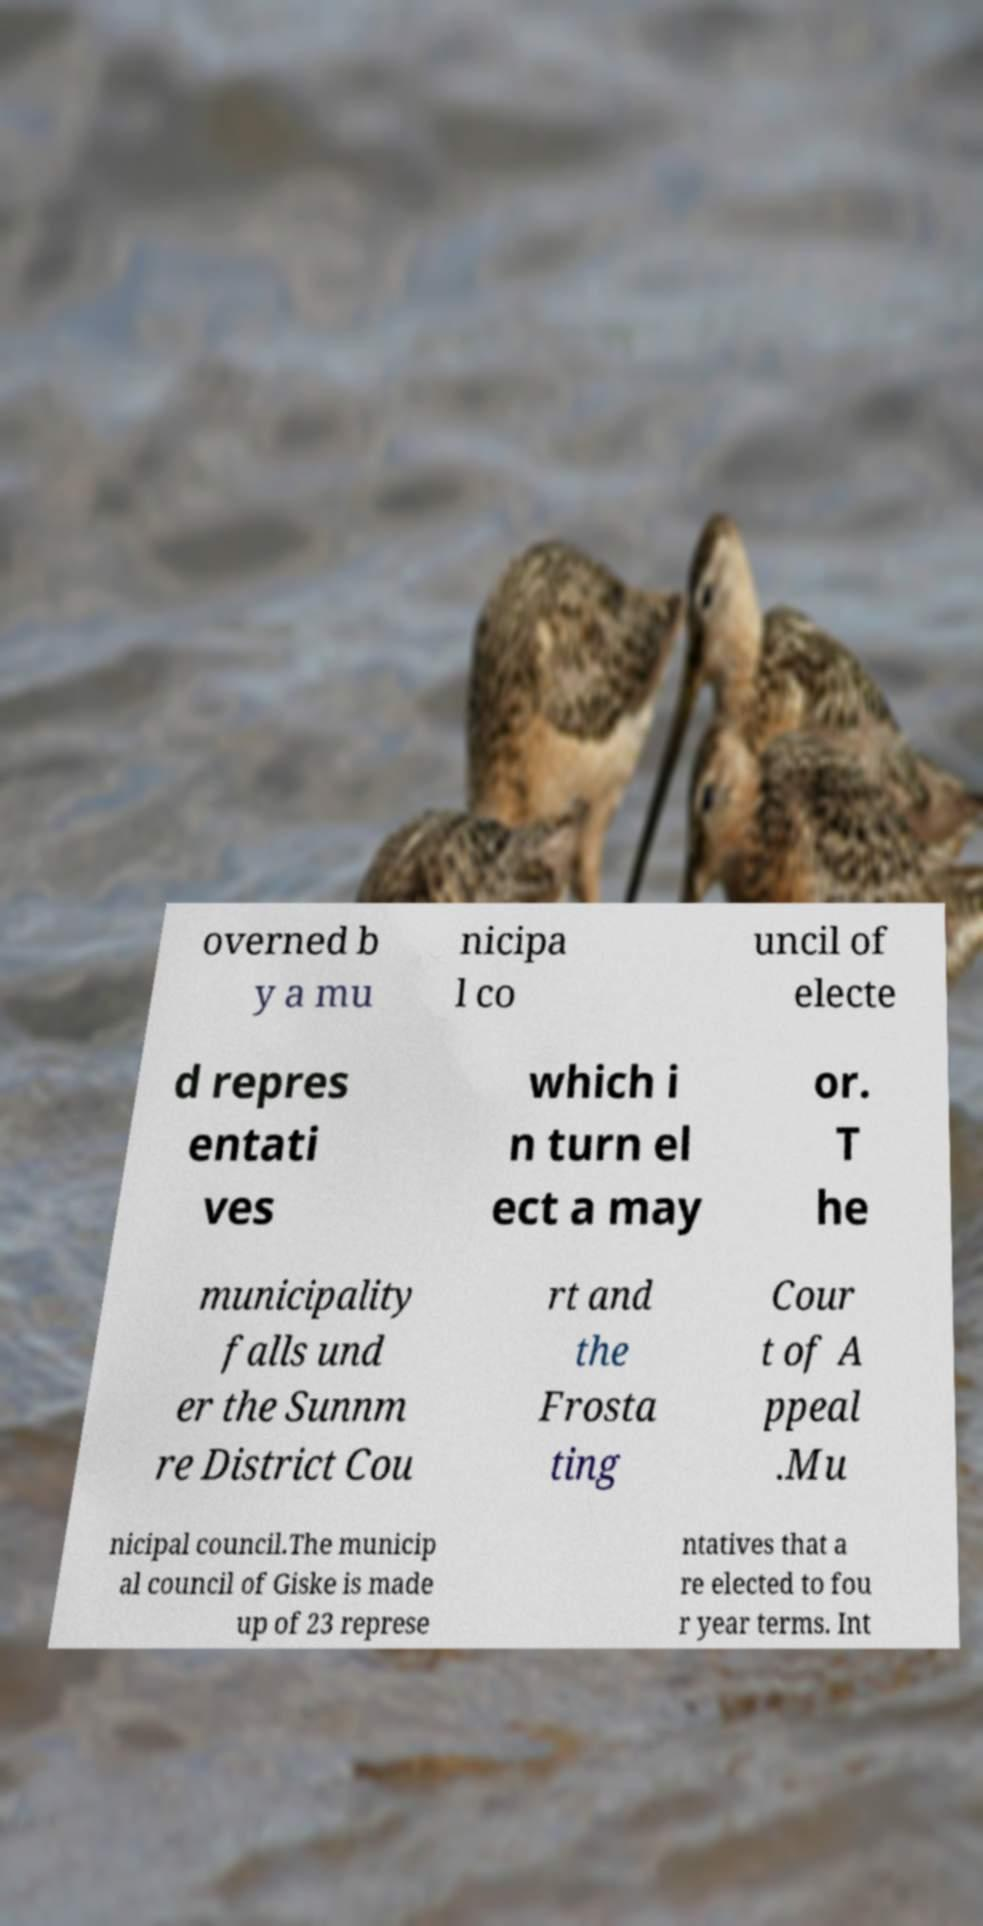Can you read and provide the text displayed in the image?This photo seems to have some interesting text. Can you extract and type it out for me? overned b y a mu nicipa l co uncil of electe d repres entati ves which i n turn el ect a may or. T he municipality falls und er the Sunnm re District Cou rt and the Frosta ting Cour t of A ppeal .Mu nicipal council.The municip al council of Giske is made up of 23 represe ntatives that a re elected to fou r year terms. Int 